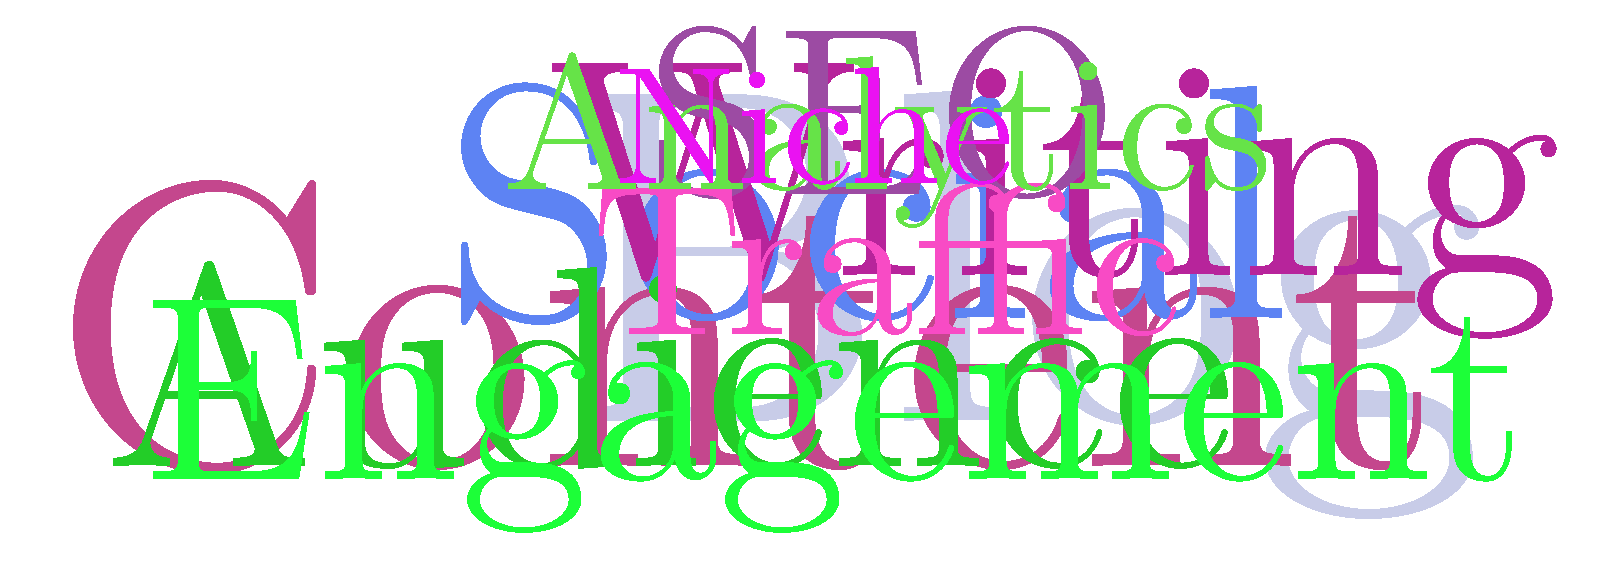As a book editor preparing to publish an anthology of blog posts, you're analyzing the content using a word cloud. Based on the visualization, which word appears to be the most prominent, likely indicating its frequent use across the blogger's posts? To determine the most frequently used word in the blogger's posts:

1. Examine the word cloud visualization.
2. Compare the sizes of different words in the cloud.
3. Identify that larger words represent higher frequency of use.
4. Note that colors are randomly assigned and don't indicate frequency.
5. Observe that "Blog" appears to be the largest word in the cloud.
6. Conclude that "Blog" is likely the most frequently used word in the posts.

This information can help you understand the main focus of the blogger's content and potentially guide your editorial decisions for the anthology.
Answer: Blog 